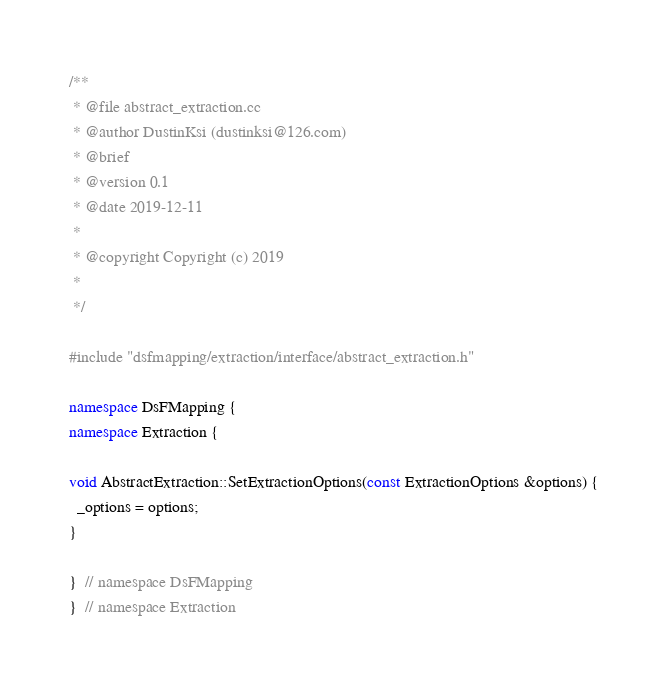<code> <loc_0><loc_0><loc_500><loc_500><_C++_>/**
 * @file abstract_extraction.cc
 * @author DustinKsi (dustinksi@126.com)
 * @brief
 * @version 0.1
 * @date 2019-12-11
 *
 * @copyright Copyright (c) 2019
 *
 */

#include "dsfmapping/extraction/interface/abstract_extraction.h"

namespace DsFMapping {
namespace Extraction {

void AbstractExtraction::SetExtractionOptions(const ExtractionOptions &options) {
  _options = options;
}

}  // namespace DsFMapping
}  // namespace Extraction
</code> 